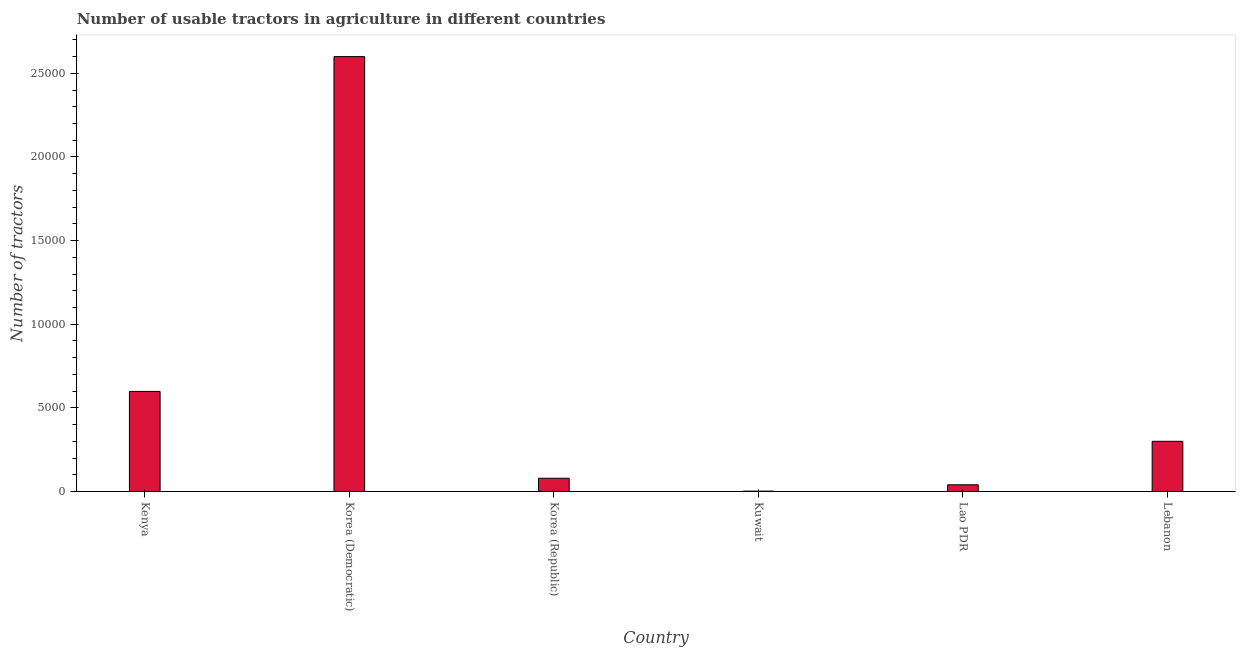Does the graph contain grids?
Keep it short and to the point. No. What is the title of the graph?
Offer a very short reply. Number of usable tractors in agriculture in different countries. What is the label or title of the X-axis?
Keep it short and to the point. Country. What is the label or title of the Y-axis?
Keep it short and to the point. Number of tractors. What is the number of tractors in Korea (Democratic)?
Your answer should be compact. 2.60e+04. Across all countries, what is the maximum number of tractors?
Ensure brevity in your answer.  2.60e+04. In which country was the number of tractors maximum?
Your answer should be compact. Korea (Democratic). In which country was the number of tractors minimum?
Offer a very short reply. Kuwait. What is the sum of the number of tractors?
Your answer should be very brief. 3.62e+04. What is the difference between the number of tractors in Kuwait and Lao PDR?
Provide a succinct answer. -380. What is the average number of tractors per country?
Your answer should be compact. 6032. What is the median number of tractors?
Provide a short and direct response. 1895. In how many countries, is the number of tractors greater than 8000 ?
Make the answer very short. 1. What is the ratio of the number of tractors in Korea (Democratic) to that in Lebanon?
Your answer should be compact. 8.67. What is the difference between the highest and the second highest number of tractors?
Offer a terse response. 2.00e+04. Is the sum of the number of tractors in Kenya and Korea (Republic) greater than the maximum number of tractors across all countries?
Your answer should be very brief. No. What is the difference between the highest and the lowest number of tractors?
Offer a very short reply. 2.60e+04. How many bars are there?
Provide a short and direct response. 6. What is the Number of tractors in Kenya?
Ensure brevity in your answer.  5982. What is the Number of tractors in Korea (Democratic)?
Provide a short and direct response. 2.60e+04. What is the Number of tractors in Korea (Republic)?
Make the answer very short. 790. What is the Number of tractors of Kuwait?
Offer a very short reply. 20. What is the Number of tractors of Lebanon?
Ensure brevity in your answer.  3000. What is the difference between the Number of tractors in Kenya and Korea (Democratic)?
Make the answer very short. -2.00e+04. What is the difference between the Number of tractors in Kenya and Korea (Republic)?
Your response must be concise. 5192. What is the difference between the Number of tractors in Kenya and Kuwait?
Your answer should be very brief. 5962. What is the difference between the Number of tractors in Kenya and Lao PDR?
Ensure brevity in your answer.  5582. What is the difference between the Number of tractors in Kenya and Lebanon?
Ensure brevity in your answer.  2982. What is the difference between the Number of tractors in Korea (Democratic) and Korea (Republic)?
Provide a succinct answer. 2.52e+04. What is the difference between the Number of tractors in Korea (Democratic) and Kuwait?
Keep it short and to the point. 2.60e+04. What is the difference between the Number of tractors in Korea (Democratic) and Lao PDR?
Your response must be concise. 2.56e+04. What is the difference between the Number of tractors in Korea (Democratic) and Lebanon?
Your answer should be compact. 2.30e+04. What is the difference between the Number of tractors in Korea (Republic) and Kuwait?
Provide a short and direct response. 770. What is the difference between the Number of tractors in Korea (Republic) and Lao PDR?
Your response must be concise. 390. What is the difference between the Number of tractors in Korea (Republic) and Lebanon?
Ensure brevity in your answer.  -2210. What is the difference between the Number of tractors in Kuwait and Lao PDR?
Your response must be concise. -380. What is the difference between the Number of tractors in Kuwait and Lebanon?
Your answer should be very brief. -2980. What is the difference between the Number of tractors in Lao PDR and Lebanon?
Your answer should be very brief. -2600. What is the ratio of the Number of tractors in Kenya to that in Korea (Democratic)?
Provide a succinct answer. 0.23. What is the ratio of the Number of tractors in Kenya to that in Korea (Republic)?
Your answer should be compact. 7.57. What is the ratio of the Number of tractors in Kenya to that in Kuwait?
Ensure brevity in your answer.  299.1. What is the ratio of the Number of tractors in Kenya to that in Lao PDR?
Offer a very short reply. 14.96. What is the ratio of the Number of tractors in Kenya to that in Lebanon?
Your answer should be very brief. 1.99. What is the ratio of the Number of tractors in Korea (Democratic) to that in Korea (Republic)?
Keep it short and to the point. 32.91. What is the ratio of the Number of tractors in Korea (Democratic) to that in Kuwait?
Provide a short and direct response. 1300. What is the ratio of the Number of tractors in Korea (Democratic) to that in Lebanon?
Keep it short and to the point. 8.67. What is the ratio of the Number of tractors in Korea (Republic) to that in Kuwait?
Offer a terse response. 39.5. What is the ratio of the Number of tractors in Korea (Republic) to that in Lao PDR?
Provide a short and direct response. 1.98. What is the ratio of the Number of tractors in Korea (Republic) to that in Lebanon?
Ensure brevity in your answer.  0.26. What is the ratio of the Number of tractors in Kuwait to that in Lebanon?
Your response must be concise. 0.01. What is the ratio of the Number of tractors in Lao PDR to that in Lebanon?
Provide a short and direct response. 0.13. 